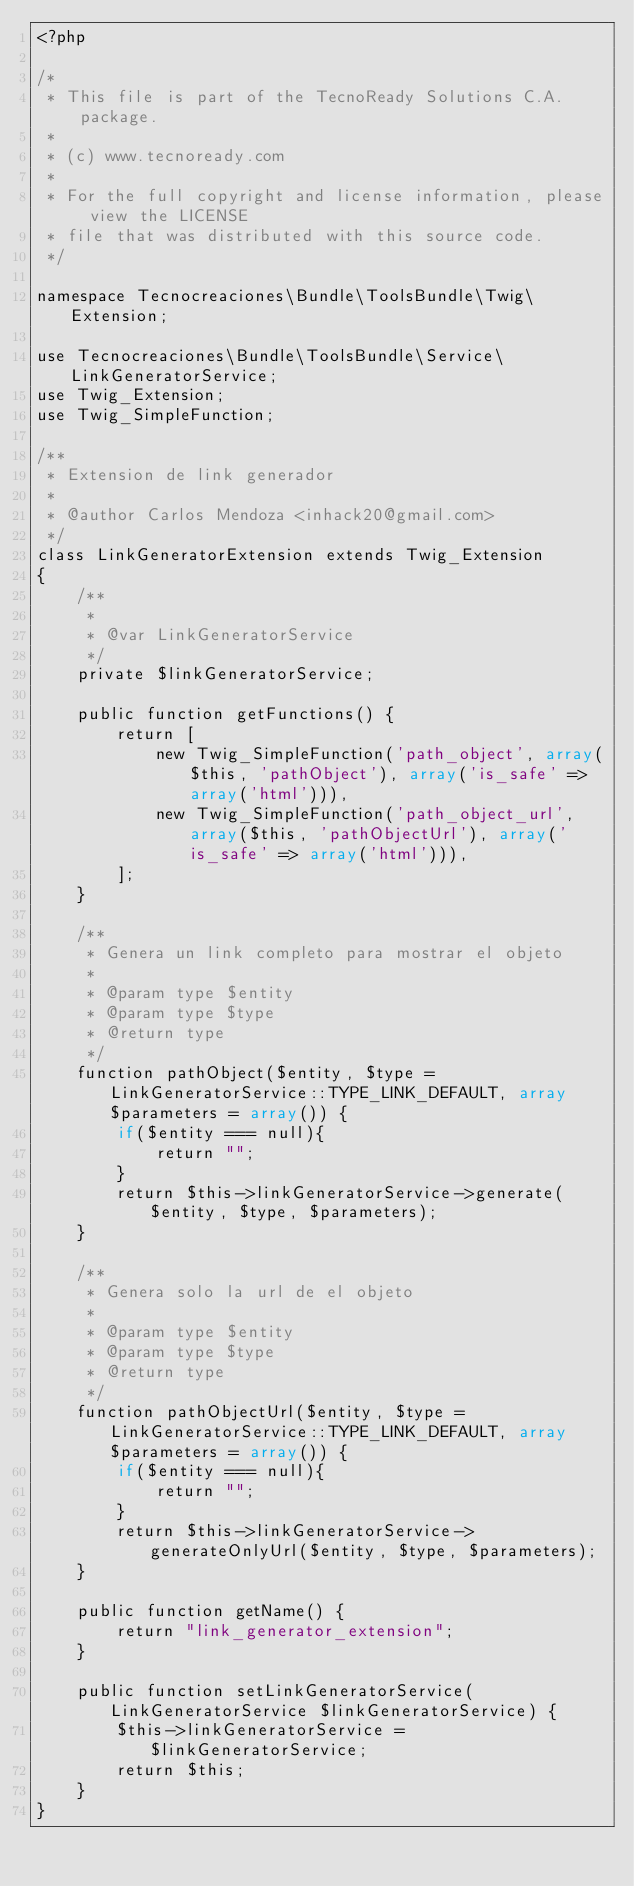Convert code to text. <code><loc_0><loc_0><loc_500><loc_500><_PHP_><?php

/*
 * This file is part of the TecnoReady Solutions C.A. package.
 * 
 * (c) www.tecnoready.com
 * 
 * For the full copyright and license information, please view the LICENSE
 * file that was distributed with this source code.
 */

namespace Tecnocreaciones\Bundle\ToolsBundle\Twig\Extension;

use Tecnocreaciones\Bundle\ToolsBundle\Service\LinkGeneratorService;
use Twig_Extension;
use Twig_SimpleFunction;

/**
 * Extension de link generador
 *
 * @author Carlos Mendoza <inhack20@gmail.com>
 */
class LinkGeneratorExtension extends Twig_Extension
{
    /**
     *
     * @var LinkGeneratorService
     */
    private $linkGeneratorService;
    
    public function getFunctions() {
        return [
            new Twig_SimpleFunction('path_object', array($this, 'pathObject'), array('is_safe' => array('html'))),
            new Twig_SimpleFunction('path_object_url', array($this, 'pathObjectUrl'), array('is_safe' => array('html'))),
        ];
    }
    
    /**
     * Genera un link completo para mostrar el objeto
     * 
     * @param type $entity
     * @param type $type
     * @return type
     */
    function pathObject($entity, $type = LinkGeneratorService::TYPE_LINK_DEFAULT, array $parameters = array()) {
        if($entity === null){
            return "";
        }
        return $this->linkGeneratorService->generate($entity, $type, $parameters);
    }

    /**
     * Genera solo la url de el objeto
     * 
     * @param type $entity
     * @param type $type
     * @return type
     */
    function pathObjectUrl($entity, $type = LinkGeneratorService::TYPE_LINK_DEFAULT, array $parameters = array()) {
        if($entity === null){
            return "";
        }
        return $this->linkGeneratorService->generateOnlyUrl($entity, $type, $parameters);
    }
    
    public function getName() {
        return "link_generator_extension";
    }
    
    public function setLinkGeneratorService(LinkGeneratorService $linkGeneratorService) {
        $this->linkGeneratorService = $linkGeneratorService;
        return $this;
    }
}
</code> 